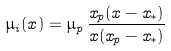Convert formula to latex. <formula><loc_0><loc_0><loc_500><loc_500>\mu _ { i } ( x ) = \mu _ { p } \, \frac { x _ { p } ( x - x _ { * } ) } { x ( x _ { p } - x _ { * } ) }</formula> 